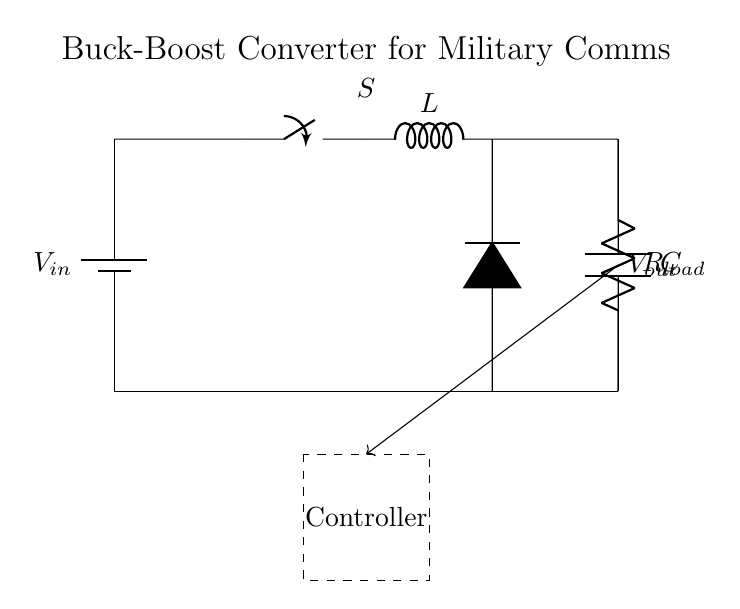What is the input voltage in the circuit? The circuit diagram shows a battery labeled as \( V_{in} \), indicating that it is the input voltage source.
Answer: \( V_{in} \) What component is used to store energy in this circuit? The inductor, represented by \( L \) in the circuit, is used to store energy in the magnetic field during operation.
Answer: Inductor What is the purpose of the diode in this circuit? The diode, marked as \( D \), only allows current to flow in one direction, preventing backflow of current and ensuring proper function of the buck-boost converter.
Answer: Prevent backflow What role does the controller play in this buck-boost converter? The dashed rectangle labeled "Controller" indicates that it regulates the operation of the converter, adjusting the switch's state based on feedback from the output.
Answer: Regulation How many main active components are present in this circuit? The main active components are the switch and the diode, totaling two components that actively control the power flow in the circuit.
Answer: Two What is the load in this circuit represented by? The load is represented by the resistor labeled as \( R_{load} \), where the output voltage is applied to do useful work in the device.
Answer: Resistor What configuration is this circuit classified as? This circuit is classified as a buck-boost converter, which is capable of stepping down or stepping up the voltage from the input level to the output level.
Answer: Buck-boost converter 